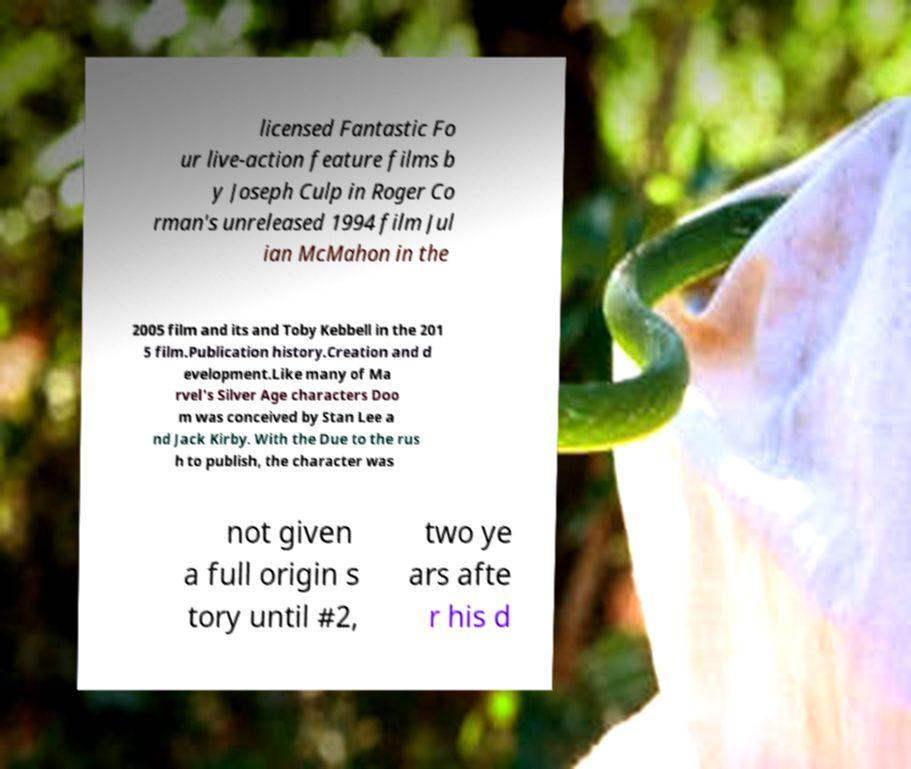There's text embedded in this image that I need extracted. Can you transcribe it verbatim? licensed Fantastic Fo ur live-action feature films b y Joseph Culp in Roger Co rman's unreleased 1994 film Jul ian McMahon in the 2005 film and its and Toby Kebbell in the 201 5 film.Publication history.Creation and d evelopment.Like many of Ma rvel's Silver Age characters Doo m was conceived by Stan Lee a nd Jack Kirby. With the Due to the rus h to publish, the character was not given a full origin s tory until #2, two ye ars afte r his d 